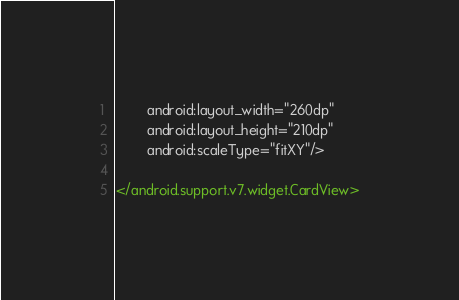<code> <loc_0><loc_0><loc_500><loc_500><_XML_>        android:layout_width="260dp"
        android:layout_height="210dp"
        android:scaleType="fitXY"/>

</android.support.v7.widget.CardView></code> 